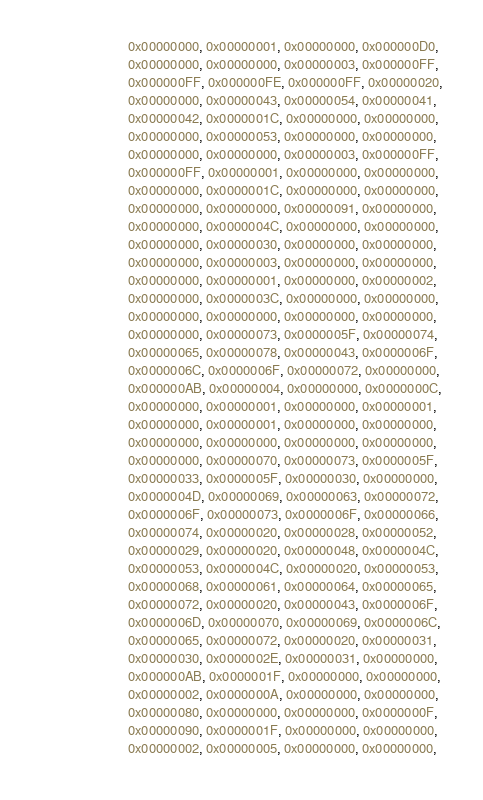Convert code to text. <code><loc_0><loc_0><loc_500><loc_500><_Nim_>                           0x00000000, 0x00000001, 0x00000000, 0x000000D0,
                           0x00000000, 0x00000000, 0x00000003, 0x000000FF,
                           0x000000FF, 0x000000FE, 0x000000FF, 0x00000020,
                           0x00000000, 0x00000043, 0x00000054, 0x00000041,
                           0x00000042, 0x0000001C, 0x00000000, 0x00000000,
                           0x00000000, 0x00000053, 0x00000000, 0x00000000,
                           0x00000000, 0x00000000, 0x00000003, 0x000000FF,
                           0x000000FF, 0x00000001, 0x00000000, 0x00000000,
                           0x00000000, 0x0000001C, 0x00000000, 0x00000000,
                           0x00000000, 0x00000000, 0x00000091, 0x00000000,
                           0x00000000, 0x0000004C, 0x00000000, 0x00000000,
                           0x00000000, 0x00000030, 0x00000000, 0x00000000,
                           0x00000000, 0x00000003, 0x00000000, 0x00000000,
                           0x00000000, 0x00000001, 0x00000000, 0x00000002,
                           0x00000000, 0x0000003C, 0x00000000, 0x00000000,
                           0x00000000, 0x00000000, 0x00000000, 0x00000000,
                           0x00000000, 0x00000073, 0x0000005F, 0x00000074,
                           0x00000065, 0x00000078, 0x00000043, 0x0000006F,
                           0x0000006C, 0x0000006F, 0x00000072, 0x00000000,
                           0x000000AB, 0x00000004, 0x00000000, 0x0000000C,
                           0x00000000, 0x00000001, 0x00000000, 0x00000001,
                           0x00000000, 0x00000001, 0x00000000, 0x00000000,
                           0x00000000, 0x00000000, 0x00000000, 0x00000000,
                           0x00000000, 0x00000070, 0x00000073, 0x0000005F,
                           0x00000033, 0x0000005F, 0x00000030, 0x00000000,
                           0x0000004D, 0x00000069, 0x00000063, 0x00000072,
                           0x0000006F, 0x00000073, 0x0000006F, 0x00000066,
                           0x00000074, 0x00000020, 0x00000028, 0x00000052,
                           0x00000029, 0x00000020, 0x00000048, 0x0000004C,
                           0x00000053, 0x0000004C, 0x00000020, 0x00000053,
                           0x00000068, 0x00000061, 0x00000064, 0x00000065,
                           0x00000072, 0x00000020, 0x00000043, 0x0000006F,
                           0x0000006D, 0x00000070, 0x00000069, 0x0000006C,
                           0x00000065, 0x00000072, 0x00000020, 0x00000031,
                           0x00000030, 0x0000002E, 0x00000031, 0x00000000,
                           0x000000AB, 0x0000001F, 0x00000000, 0x00000000,
                           0x00000002, 0x0000000A, 0x00000000, 0x00000000,
                           0x00000080, 0x00000000, 0x00000000, 0x0000000F,
                           0x00000090, 0x0000001F, 0x00000000, 0x00000000,
                           0x00000002, 0x00000005, 0x00000000, 0x00000000,</code> 